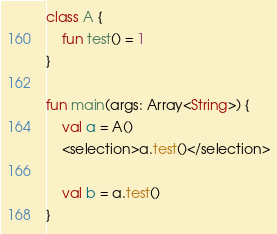<code> <loc_0><loc_0><loc_500><loc_500><_Kotlin_>class A {
    fun test() = 1
}

fun main(args: Array<String>) {
    val a = A()
    <selection>a.test()</selection>

    val b = a.test()
}
</code> 